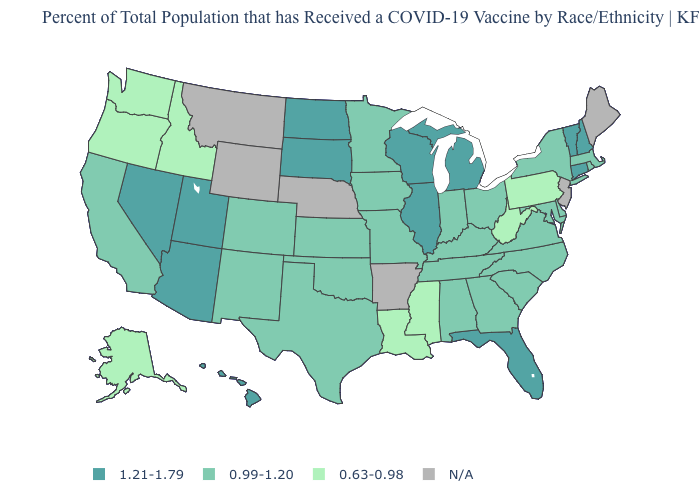How many symbols are there in the legend?
Give a very brief answer. 4. Name the states that have a value in the range 0.99-1.20?
Write a very short answer. Alabama, California, Colorado, Delaware, Georgia, Indiana, Iowa, Kansas, Kentucky, Maryland, Massachusetts, Minnesota, Missouri, New Mexico, New York, North Carolina, Ohio, Oklahoma, Rhode Island, South Carolina, Tennessee, Texas, Virginia. Among the states that border New York , does Pennsylvania have the lowest value?
Concise answer only. Yes. Does the map have missing data?
Short answer required. Yes. Among the states that border Nevada , does Oregon have the highest value?
Answer briefly. No. Does Georgia have the lowest value in the USA?
Short answer required. No. Does North Dakota have the highest value in the MidWest?
Write a very short answer. Yes. Does California have the lowest value in the USA?
Answer briefly. No. Name the states that have a value in the range 0.99-1.20?
Quick response, please. Alabama, California, Colorado, Delaware, Georgia, Indiana, Iowa, Kansas, Kentucky, Maryland, Massachusetts, Minnesota, Missouri, New Mexico, New York, North Carolina, Ohio, Oklahoma, Rhode Island, South Carolina, Tennessee, Texas, Virginia. Is the legend a continuous bar?
Keep it brief. No. Which states hav the highest value in the South?
Write a very short answer. Florida. Among the states that border Vermont , does New Hampshire have the lowest value?
Concise answer only. No. What is the value of Wyoming?
Short answer required. N/A. Which states have the lowest value in the Northeast?
Short answer required. Pennsylvania. 